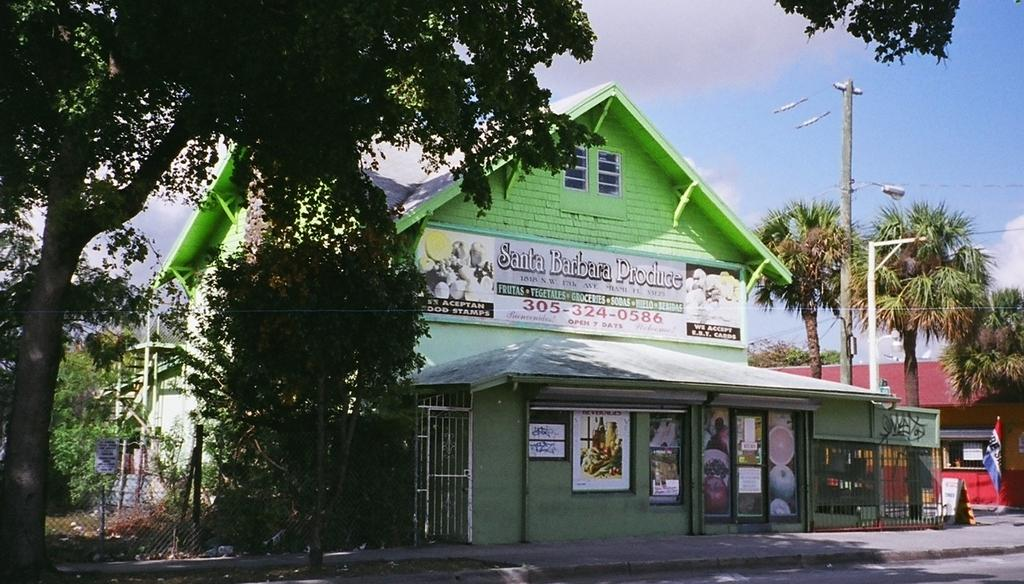What type of structures can be seen in the image? There are buildings in the image. What additional elements can be found in the image? Advertisements, flags, street poles, street lights, electric poles, electric cables, fences, grills, and trees are present in the image. What can be seen in the sky in the image? The sky is visible in the image, and clouds are present. What type of grain is visible in the image? There is no grain present in the image. What color is the copper in the image? There is no copper present in the image. 